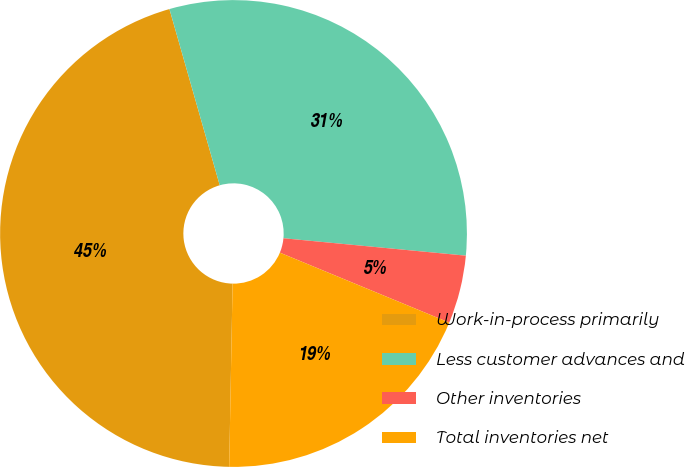Convert chart to OTSL. <chart><loc_0><loc_0><loc_500><loc_500><pie_chart><fcel>Work-in-process primarily<fcel>Less customer advances and<fcel>Other inventories<fcel>Total inventories net<nl><fcel>45.28%<fcel>30.94%<fcel>4.72%<fcel>19.06%<nl></chart> 